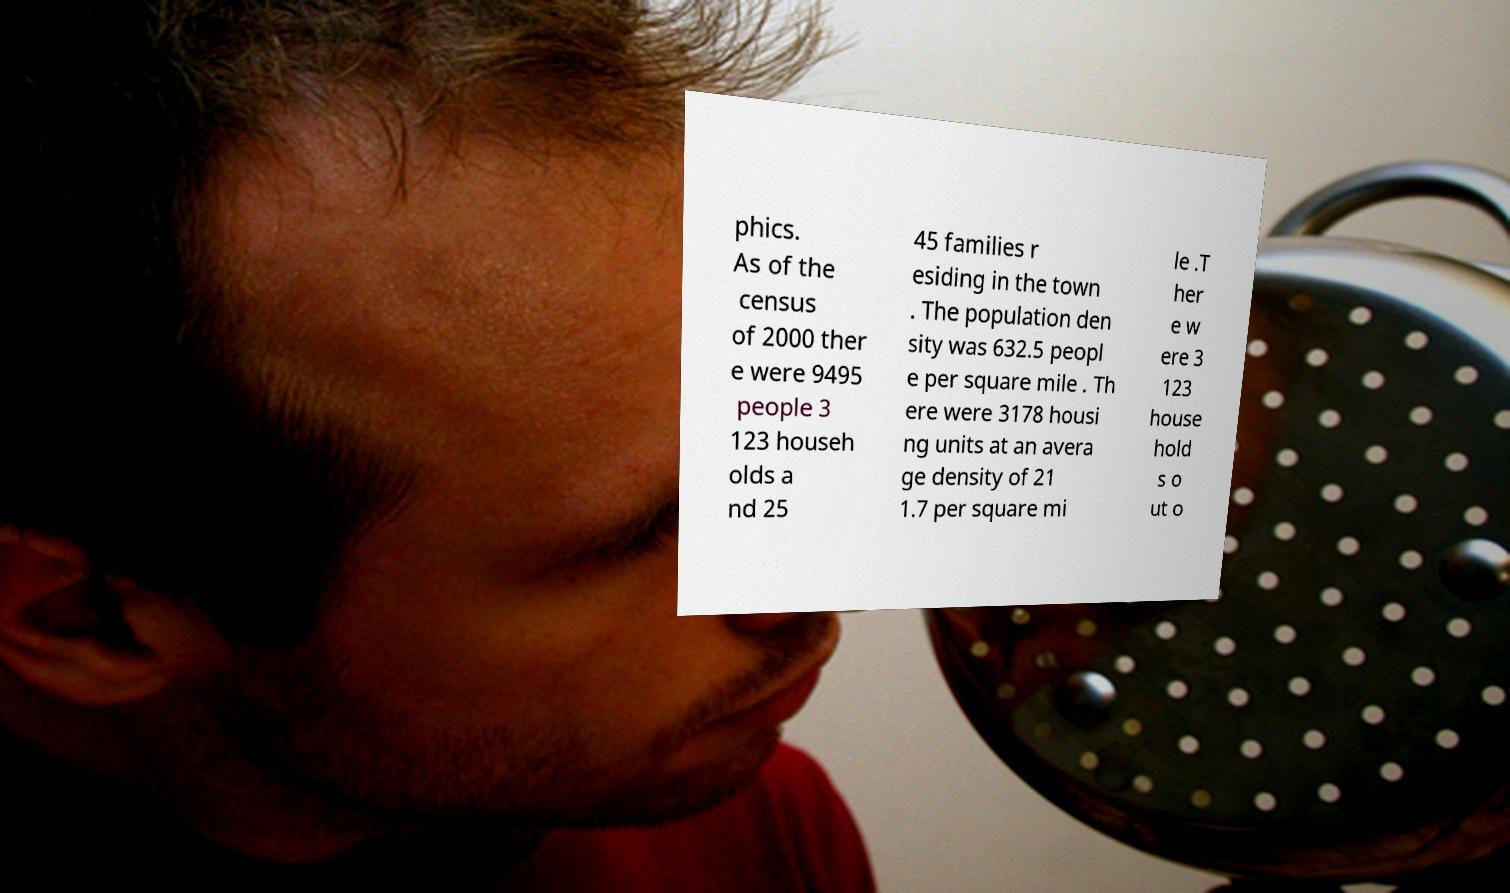For documentation purposes, I need the text within this image transcribed. Could you provide that? phics. As of the census of 2000 ther e were 9495 people 3 123 househ olds a nd 25 45 families r esiding in the town . The population den sity was 632.5 peopl e per square mile . Th ere were 3178 housi ng units at an avera ge density of 21 1.7 per square mi le .T her e w ere 3 123 house hold s o ut o 